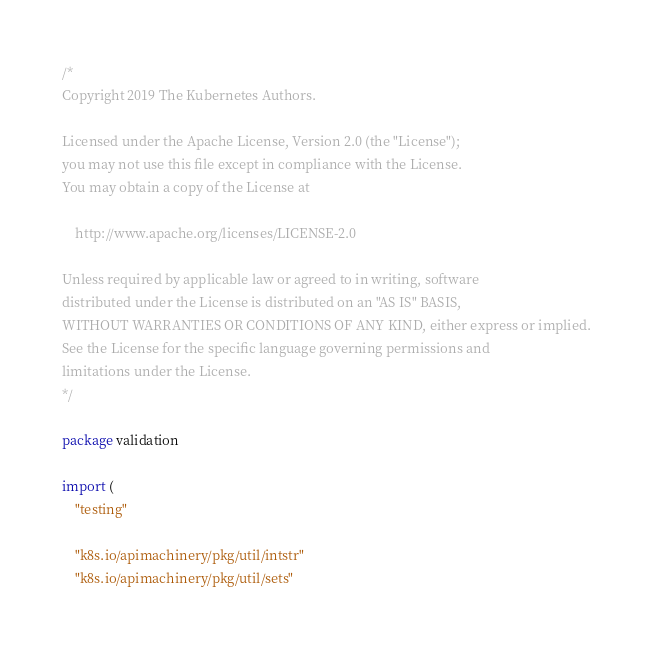<code> <loc_0><loc_0><loc_500><loc_500><_Go_>/*
Copyright 2019 The Kubernetes Authors.

Licensed under the Apache License, Version 2.0 (the "License");
you may not use this file except in compliance with the License.
You may obtain a copy of the License at

    http://www.apache.org/licenses/LICENSE-2.0

Unless required by applicable law or agreed to in writing, software
distributed under the License is distributed on an "AS IS" BASIS,
WITHOUT WARRANTIES OR CONDITIONS OF ANY KIND, either express or implied.
See the License for the specific language governing permissions and
limitations under the License.
*/

package validation

import (
	"testing"

	"k8s.io/apimachinery/pkg/util/intstr"
	"k8s.io/apimachinery/pkg/util/sets"</code> 